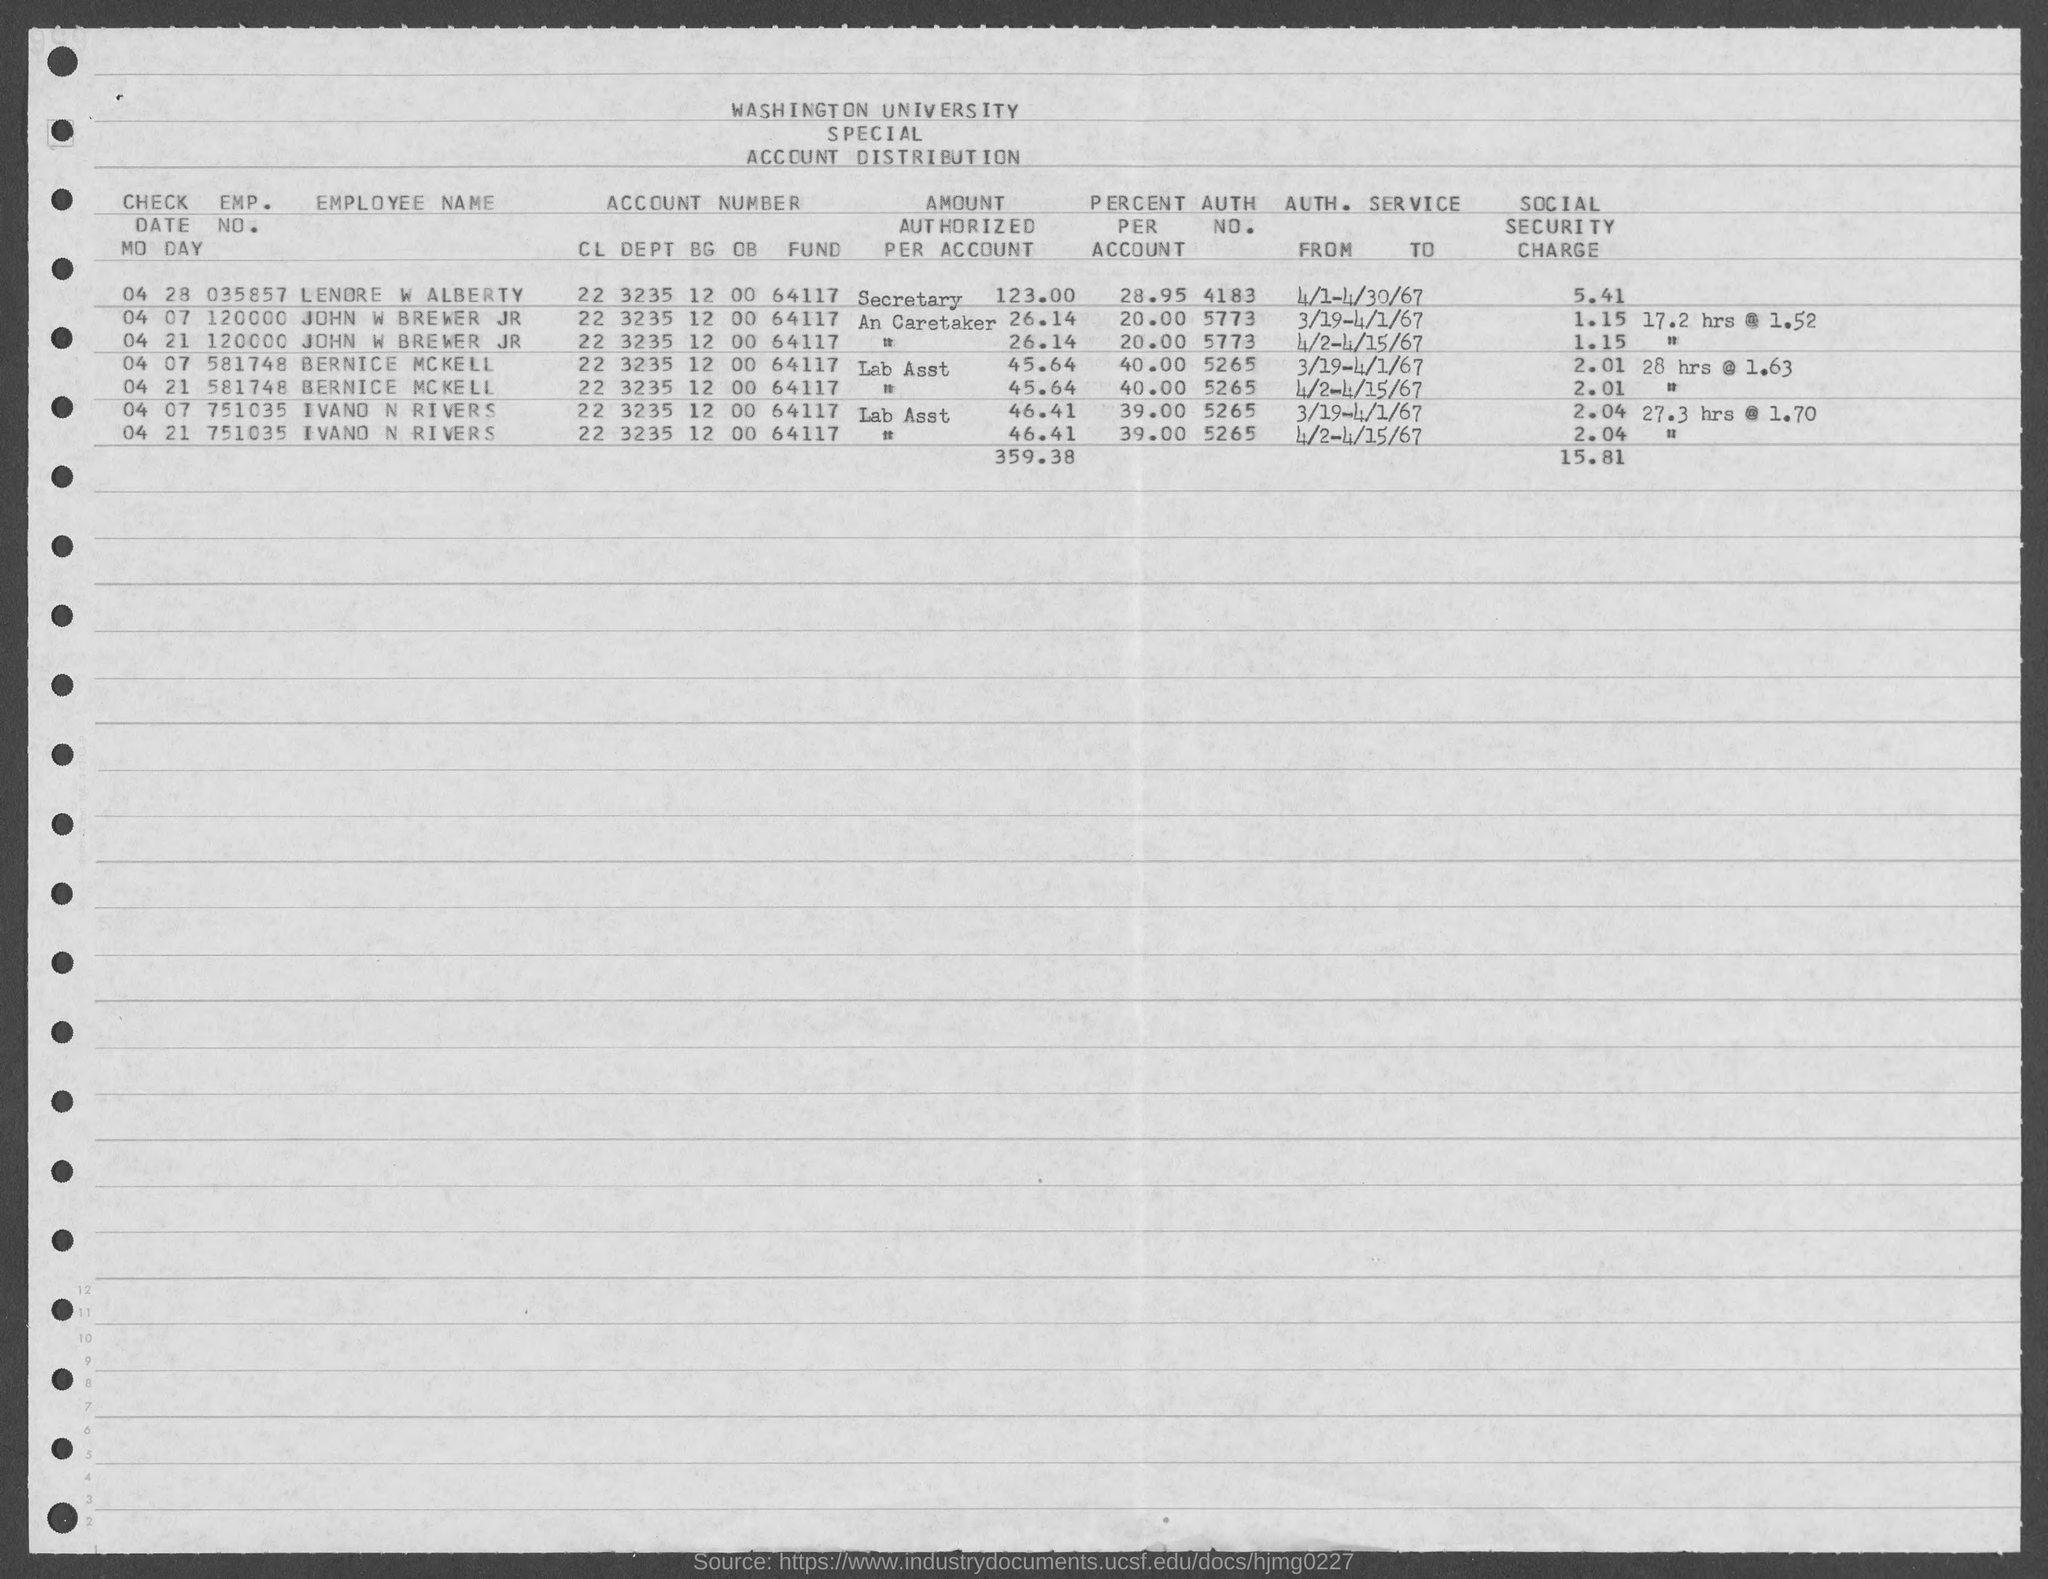What is the emp. no. of lenore w alberty ?
Offer a terse response. 035857. What is the emp. no. of  john w brewer jr ?
Your answer should be compact. 120000. What is the emp. no. of  bernice mckell ?
Ensure brevity in your answer.  581748. What is the emp. no. of  ivano n rivers ?
Keep it short and to the point. 751035. What is the auth. no. of lenore w alberty ?
Your answer should be very brief. 4183. What is the auth. no. of John W Brewer Jr ?
Your answer should be very brief. 5773. What is the auth. no. of bernice mckell?
Your answer should be very brief. 5265. What is the auth. no. of ivano n. rivers?
Keep it short and to the point. 5265. What is the percent per account of lenore w alberty ?
Ensure brevity in your answer.  28.95. What is the percent per account of john brewer jr?
Your answer should be very brief. 20.00. 